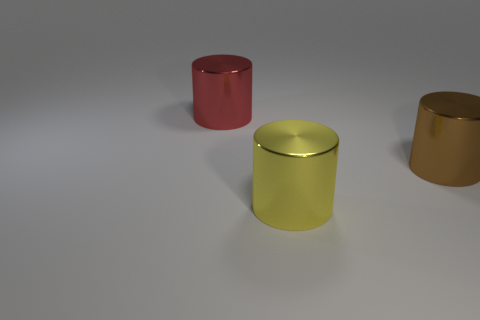There is a brown metal object that is the same shape as the big red metallic object; what size is it?
Your answer should be very brief. Large. Are there any other things that are made of the same material as the big brown thing?
Your answer should be very brief. Yes. There is a red cylinder that is behind the brown cylinder that is behind the yellow shiny object; is there a big brown metallic object that is behind it?
Provide a short and direct response. No. There is a brown cylinder that is right of the yellow cylinder; what is its material?
Offer a terse response. Metal. How many large objects are either yellow objects or blue metal objects?
Keep it short and to the point. 1. There is a object behind the brown metal cylinder; does it have the same size as the brown shiny cylinder?
Give a very brief answer. Yes. What is the material of the yellow thing?
Your answer should be compact. Metal. What is the material of the thing that is in front of the red metal object and to the left of the large brown thing?
Keep it short and to the point. Metal. How many objects are large metallic things behind the large yellow shiny cylinder or yellow cylinders?
Offer a terse response. 3. Are there any green shiny cylinders that have the same size as the red object?
Provide a succinct answer. No. 